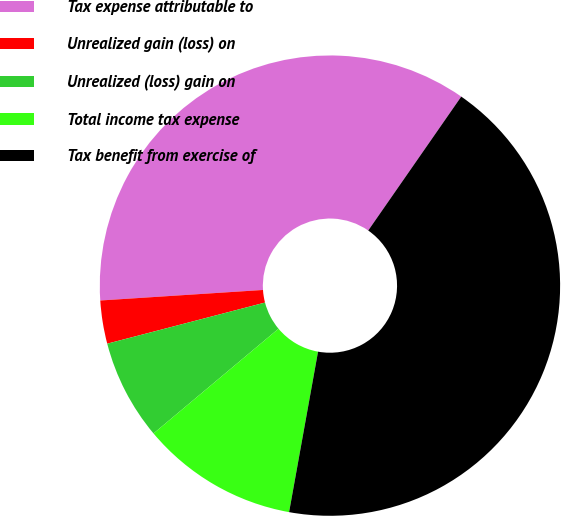<chart> <loc_0><loc_0><loc_500><loc_500><pie_chart><fcel>Tax expense attributable to<fcel>Unrealized gain (loss) on<fcel>Unrealized (loss) gain on<fcel>Total income tax expense<fcel>Tax benefit from exercise of<nl><fcel>35.69%<fcel>3.03%<fcel>7.04%<fcel>11.06%<fcel>43.18%<nl></chart> 